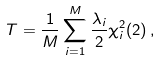<formula> <loc_0><loc_0><loc_500><loc_500>T = \frac { 1 } { M } \sum _ { i = 1 } ^ { M } \frac { \lambda _ { i } } { 2 } \chi _ { i } ^ { 2 } ( 2 ) \, ,</formula> 